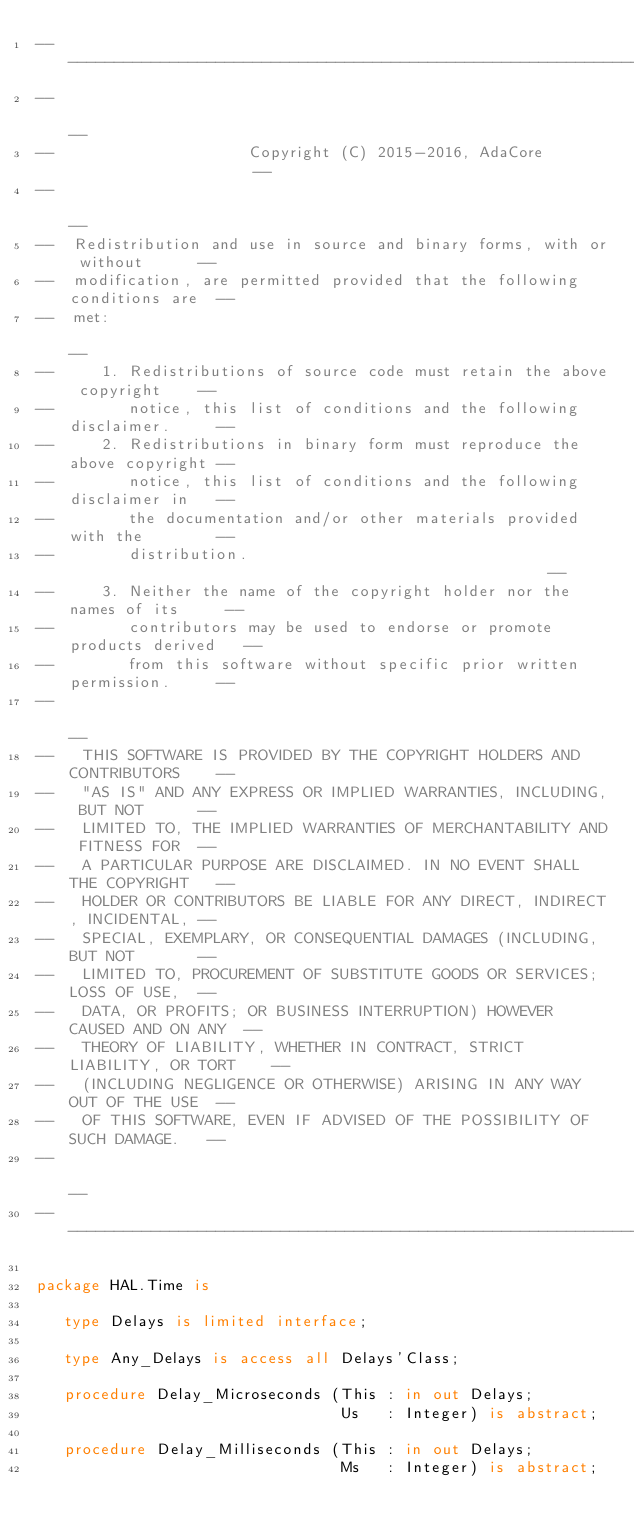Convert code to text. <code><loc_0><loc_0><loc_500><loc_500><_Ada_>------------------------------------------------------------------------------
--                                                                          --
--                     Copyright (C) 2015-2016, AdaCore                     --
--                                                                          --
--  Redistribution and use in source and binary forms, with or without      --
--  modification, are permitted provided that the following conditions are  --
--  met:                                                                    --
--     1. Redistributions of source code must retain the above copyright    --
--        notice, this list of conditions and the following disclaimer.     --
--     2. Redistributions in binary form must reproduce the above copyright --
--        notice, this list of conditions and the following disclaimer in   --
--        the documentation and/or other materials provided with the        --
--        distribution.                                                     --
--     3. Neither the name of the copyright holder nor the names of its     --
--        contributors may be used to endorse or promote products derived   --
--        from this software without specific prior written permission.     --
--                                                                          --
--   THIS SOFTWARE IS PROVIDED BY THE COPYRIGHT HOLDERS AND CONTRIBUTORS    --
--   "AS IS" AND ANY EXPRESS OR IMPLIED WARRANTIES, INCLUDING, BUT NOT      --
--   LIMITED TO, THE IMPLIED WARRANTIES OF MERCHANTABILITY AND FITNESS FOR  --
--   A PARTICULAR PURPOSE ARE DISCLAIMED. IN NO EVENT SHALL THE COPYRIGHT   --
--   HOLDER OR CONTRIBUTORS BE LIABLE FOR ANY DIRECT, INDIRECT, INCIDENTAL, --
--   SPECIAL, EXEMPLARY, OR CONSEQUENTIAL DAMAGES (INCLUDING, BUT NOT       --
--   LIMITED TO, PROCUREMENT OF SUBSTITUTE GOODS OR SERVICES; LOSS OF USE,  --
--   DATA, OR PROFITS; OR BUSINESS INTERRUPTION) HOWEVER CAUSED AND ON ANY  --
--   THEORY OF LIABILITY, WHETHER IN CONTRACT, STRICT LIABILITY, OR TORT    --
--   (INCLUDING NEGLIGENCE OR OTHERWISE) ARISING IN ANY WAY OUT OF THE USE  --
--   OF THIS SOFTWARE, EVEN IF ADVISED OF THE POSSIBILITY OF SUCH DAMAGE.   --
--                                                                          --
------------------------------------------------------------------------------

package HAL.Time is

   type Delays is limited interface;

   type Any_Delays is access all Delays'Class;

   procedure Delay_Microseconds (This : in out Delays;
                                 Us   : Integer) is abstract;

   procedure Delay_Milliseconds (This : in out Delays;
                                 Ms   : Integer) is abstract;
</code> 